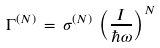Convert formula to latex. <formula><loc_0><loc_0><loc_500><loc_500>\Gamma ^ { ( N ) } \, = \, \sigma ^ { ( N ) } \, \left ( \frac { I } { \hbar { \omega } } \right ) ^ { N }</formula> 